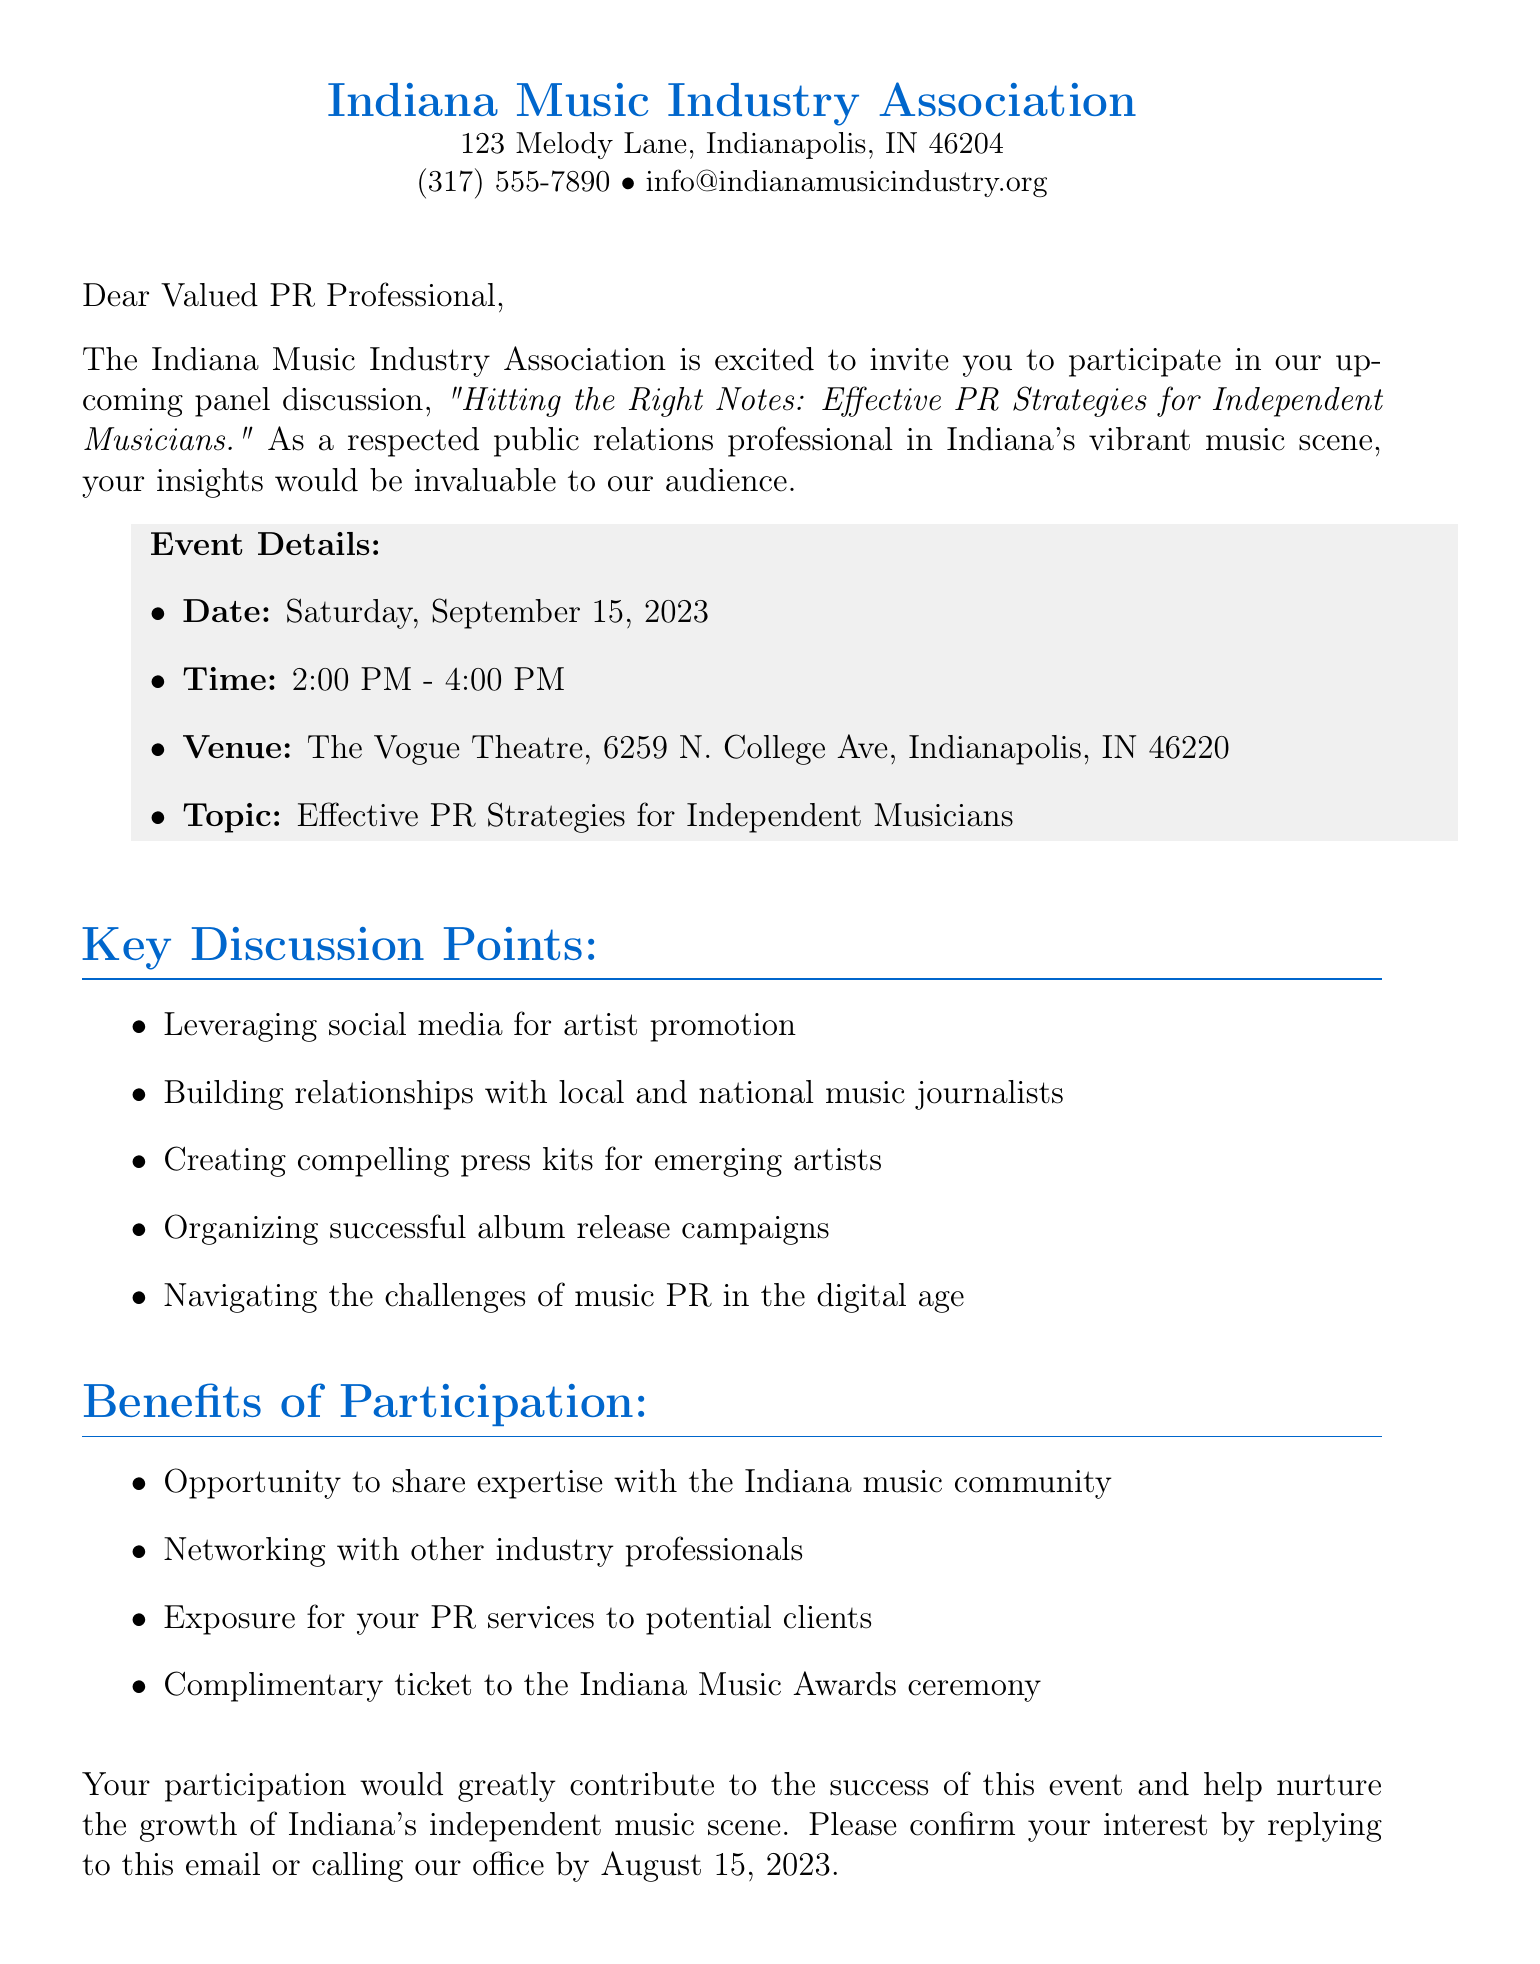what is the name of the event? The name of the event is specified in the introduction paragraph of the document, which is "Hitting the Right Notes: Effective PR Strategies for Independent Musicians."
Answer: Hitting the Right Notes: Effective PR Strategies for Independent Musicians what is the date of the event? The date of the event is mentioned under the event details section, which states "Saturday, September 15, 2023."
Answer: Saturday, September 15, 2023 what is the venue of the event? The venue is provided in the event details section, which indicates "The Vogue Theatre, 6259 N. College Ave, Indianapolis, IN 46220."
Answer: The Vogue Theatre, 6259 N. College Ave, Indianapolis, IN 46220 what is one key discussion point mentioned? One of the key discussion points is listed in the section titled "Key Discussion Points" and includes topics such as "Leveraging social media for artist promotion."
Answer: Leveraging social media for artist promotion what is one benefit of participation? The benefits of participation are outlined in a specific section, where one benefit is stated as "Opportunity to share expertise with the Indiana music community."
Answer: Opportunity to share expertise with the Indiana music community who is the sender of the letter? The sender of the letter is identified in the signature section, which includes the name "Sarah Harmony."
Answer: Sarah Harmony when should you confirm your interest? The deadline for confirming interest is given in the closing paragraph of the document, stating "by August 15, 2023."
Answer: by August 15, 2023 what is the contact number provided? The contact number for the organization is included at the top of the document and is "(317) 555-7890."
Answer: (317) 555-7890 what is the purpose of the event? The purpose of the event is highlighted in the introduction paragraph, suggesting that it aims to discuss "Effective PR Strategies for Independent Musicians."
Answer: Effective PR Strategies for Independent Musicians 